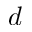Convert formula to latex. <formula><loc_0><loc_0><loc_500><loc_500>d</formula> 